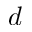Convert formula to latex. <formula><loc_0><loc_0><loc_500><loc_500>d</formula> 